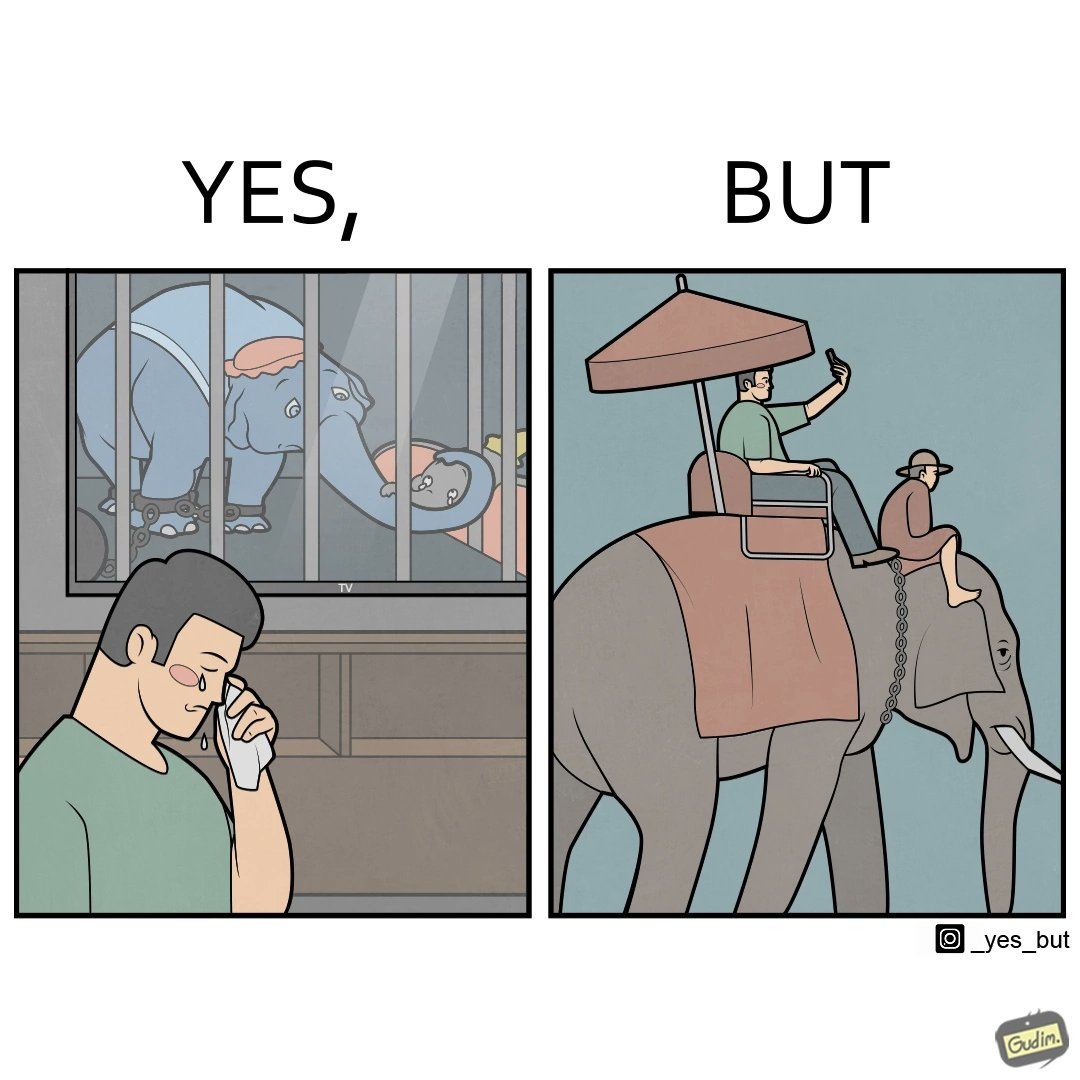Describe what you see in this image. The image is ironic, because the people who get sentimental over imprisoned animal while watching TV shows often feel okay when using animals for labor 